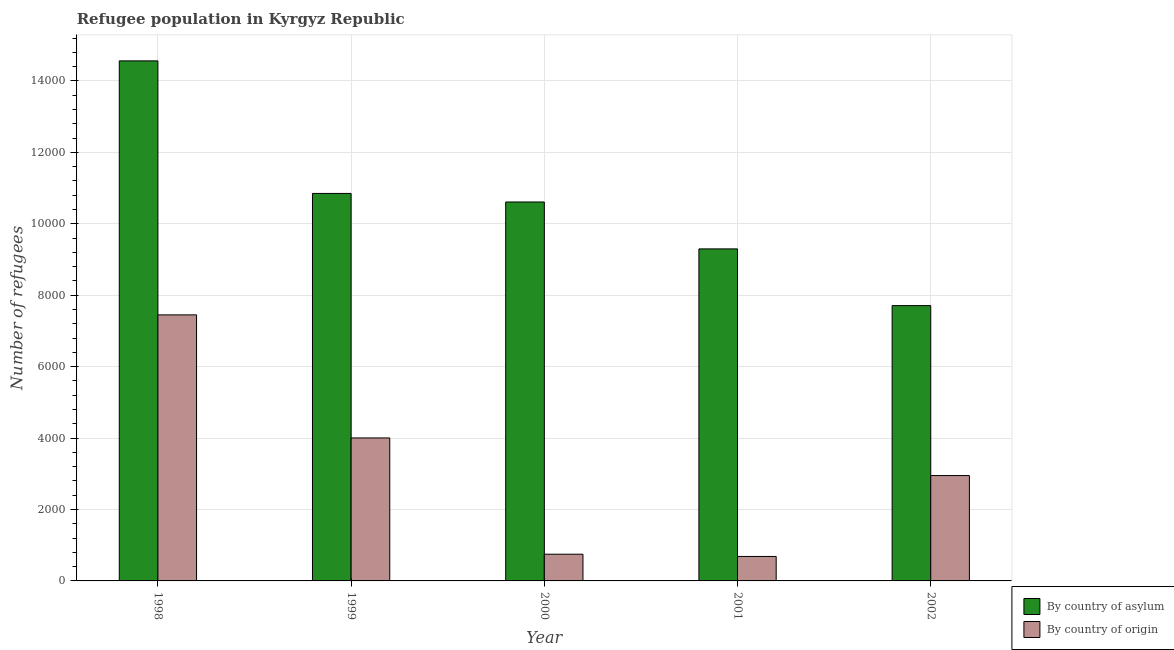How many different coloured bars are there?
Give a very brief answer. 2. What is the label of the 4th group of bars from the left?
Give a very brief answer. 2001. In how many cases, is the number of bars for a given year not equal to the number of legend labels?
Your answer should be compact. 0. What is the number of refugees by country of asylum in 2001?
Provide a short and direct response. 9296. Across all years, what is the maximum number of refugees by country of asylum?
Give a very brief answer. 1.46e+04. Across all years, what is the minimum number of refugees by country of asylum?
Your answer should be very brief. 7708. In which year was the number of refugees by country of asylum maximum?
Your answer should be compact. 1998. In which year was the number of refugees by country of asylum minimum?
Give a very brief answer. 2002. What is the total number of refugees by country of origin in the graph?
Offer a very short reply. 1.58e+04. What is the difference between the number of refugees by country of origin in 1998 and that in 2002?
Your response must be concise. 4499. What is the difference between the number of refugees by country of origin in 1998 and the number of refugees by country of asylum in 2002?
Your response must be concise. 4499. What is the average number of refugees by country of origin per year?
Make the answer very short. 3167. What is the ratio of the number of refugees by country of origin in 2001 to that in 2002?
Offer a very short reply. 0.23. Is the difference between the number of refugees by country of origin in 1999 and 2000 greater than the difference between the number of refugees by country of asylum in 1999 and 2000?
Keep it short and to the point. No. What is the difference between the highest and the second highest number of refugees by country of origin?
Your answer should be very brief. 3446. What is the difference between the highest and the lowest number of refugees by country of origin?
Give a very brief answer. 6764. Is the sum of the number of refugees by country of origin in 1998 and 2002 greater than the maximum number of refugees by country of asylum across all years?
Make the answer very short. Yes. What does the 2nd bar from the left in 1999 represents?
Offer a very short reply. By country of origin. What does the 1st bar from the right in 2001 represents?
Provide a short and direct response. By country of origin. Are all the bars in the graph horizontal?
Keep it short and to the point. No. How many years are there in the graph?
Your answer should be very brief. 5. What is the difference between two consecutive major ticks on the Y-axis?
Give a very brief answer. 2000. Does the graph contain grids?
Your answer should be very brief. Yes. Where does the legend appear in the graph?
Ensure brevity in your answer.  Bottom right. How are the legend labels stacked?
Offer a very short reply. Vertical. What is the title of the graph?
Offer a terse response. Refugee population in Kyrgyz Republic. What is the label or title of the X-axis?
Ensure brevity in your answer.  Year. What is the label or title of the Y-axis?
Your answer should be very brief. Number of refugees. What is the Number of refugees in By country of asylum in 1998?
Your answer should be compact. 1.46e+04. What is the Number of refugees of By country of origin in 1998?
Your response must be concise. 7449. What is the Number of refugees of By country of asylum in 1999?
Give a very brief answer. 1.08e+04. What is the Number of refugees in By country of origin in 1999?
Provide a succinct answer. 4003. What is the Number of refugees of By country of asylum in 2000?
Provide a succinct answer. 1.06e+04. What is the Number of refugees in By country of origin in 2000?
Your response must be concise. 748. What is the Number of refugees of By country of asylum in 2001?
Your answer should be very brief. 9296. What is the Number of refugees of By country of origin in 2001?
Give a very brief answer. 685. What is the Number of refugees in By country of asylum in 2002?
Your answer should be compact. 7708. What is the Number of refugees of By country of origin in 2002?
Make the answer very short. 2950. Across all years, what is the maximum Number of refugees of By country of asylum?
Make the answer very short. 1.46e+04. Across all years, what is the maximum Number of refugees in By country of origin?
Your answer should be very brief. 7449. Across all years, what is the minimum Number of refugees of By country of asylum?
Ensure brevity in your answer.  7708. Across all years, what is the minimum Number of refugees in By country of origin?
Your answer should be very brief. 685. What is the total Number of refugees of By country of asylum in the graph?
Offer a terse response. 5.30e+04. What is the total Number of refugees in By country of origin in the graph?
Offer a very short reply. 1.58e+04. What is the difference between the Number of refugees in By country of asylum in 1998 and that in 1999?
Offer a terse response. 3711. What is the difference between the Number of refugees in By country of origin in 1998 and that in 1999?
Your answer should be very brief. 3446. What is the difference between the Number of refugees in By country of asylum in 1998 and that in 2000?
Provide a short and direct response. 3951. What is the difference between the Number of refugees in By country of origin in 1998 and that in 2000?
Ensure brevity in your answer.  6701. What is the difference between the Number of refugees in By country of asylum in 1998 and that in 2001?
Offer a very short reply. 5264. What is the difference between the Number of refugees in By country of origin in 1998 and that in 2001?
Ensure brevity in your answer.  6764. What is the difference between the Number of refugees in By country of asylum in 1998 and that in 2002?
Keep it short and to the point. 6852. What is the difference between the Number of refugees of By country of origin in 1998 and that in 2002?
Ensure brevity in your answer.  4499. What is the difference between the Number of refugees of By country of asylum in 1999 and that in 2000?
Provide a succinct answer. 240. What is the difference between the Number of refugees in By country of origin in 1999 and that in 2000?
Offer a terse response. 3255. What is the difference between the Number of refugees of By country of asylum in 1999 and that in 2001?
Your answer should be very brief. 1553. What is the difference between the Number of refugees in By country of origin in 1999 and that in 2001?
Your response must be concise. 3318. What is the difference between the Number of refugees of By country of asylum in 1999 and that in 2002?
Provide a short and direct response. 3141. What is the difference between the Number of refugees of By country of origin in 1999 and that in 2002?
Provide a succinct answer. 1053. What is the difference between the Number of refugees of By country of asylum in 2000 and that in 2001?
Give a very brief answer. 1313. What is the difference between the Number of refugees of By country of origin in 2000 and that in 2001?
Offer a very short reply. 63. What is the difference between the Number of refugees of By country of asylum in 2000 and that in 2002?
Provide a succinct answer. 2901. What is the difference between the Number of refugees in By country of origin in 2000 and that in 2002?
Your answer should be compact. -2202. What is the difference between the Number of refugees of By country of asylum in 2001 and that in 2002?
Your answer should be very brief. 1588. What is the difference between the Number of refugees in By country of origin in 2001 and that in 2002?
Make the answer very short. -2265. What is the difference between the Number of refugees of By country of asylum in 1998 and the Number of refugees of By country of origin in 1999?
Your answer should be very brief. 1.06e+04. What is the difference between the Number of refugees of By country of asylum in 1998 and the Number of refugees of By country of origin in 2000?
Your response must be concise. 1.38e+04. What is the difference between the Number of refugees in By country of asylum in 1998 and the Number of refugees in By country of origin in 2001?
Your answer should be compact. 1.39e+04. What is the difference between the Number of refugees of By country of asylum in 1998 and the Number of refugees of By country of origin in 2002?
Make the answer very short. 1.16e+04. What is the difference between the Number of refugees of By country of asylum in 1999 and the Number of refugees of By country of origin in 2000?
Offer a terse response. 1.01e+04. What is the difference between the Number of refugees in By country of asylum in 1999 and the Number of refugees in By country of origin in 2001?
Give a very brief answer. 1.02e+04. What is the difference between the Number of refugees of By country of asylum in 1999 and the Number of refugees of By country of origin in 2002?
Offer a terse response. 7899. What is the difference between the Number of refugees in By country of asylum in 2000 and the Number of refugees in By country of origin in 2001?
Provide a short and direct response. 9924. What is the difference between the Number of refugees in By country of asylum in 2000 and the Number of refugees in By country of origin in 2002?
Provide a short and direct response. 7659. What is the difference between the Number of refugees in By country of asylum in 2001 and the Number of refugees in By country of origin in 2002?
Your answer should be very brief. 6346. What is the average Number of refugees in By country of asylum per year?
Your answer should be compact. 1.06e+04. What is the average Number of refugees in By country of origin per year?
Make the answer very short. 3167. In the year 1998, what is the difference between the Number of refugees in By country of asylum and Number of refugees in By country of origin?
Your answer should be compact. 7111. In the year 1999, what is the difference between the Number of refugees in By country of asylum and Number of refugees in By country of origin?
Your answer should be very brief. 6846. In the year 2000, what is the difference between the Number of refugees of By country of asylum and Number of refugees of By country of origin?
Make the answer very short. 9861. In the year 2001, what is the difference between the Number of refugees of By country of asylum and Number of refugees of By country of origin?
Offer a very short reply. 8611. In the year 2002, what is the difference between the Number of refugees in By country of asylum and Number of refugees in By country of origin?
Keep it short and to the point. 4758. What is the ratio of the Number of refugees in By country of asylum in 1998 to that in 1999?
Ensure brevity in your answer.  1.34. What is the ratio of the Number of refugees of By country of origin in 1998 to that in 1999?
Make the answer very short. 1.86. What is the ratio of the Number of refugees of By country of asylum in 1998 to that in 2000?
Offer a terse response. 1.37. What is the ratio of the Number of refugees in By country of origin in 1998 to that in 2000?
Your answer should be compact. 9.96. What is the ratio of the Number of refugees of By country of asylum in 1998 to that in 2001?
Provide a short and direct response. 1.57. What is the ratio of the Number of refugees in By country of origin in 1998 to that in 2001?
Your answer should be compact. 10.87. What is the ratio of the Number of refugees of By country of asylum in 1998 to that in 2002?
Offer a terse response. 1.89. What is the ratio of the Number of refugees in By country of origin in 1998 to that in 2002?
Provide a succinct answer. 2.53. What is the ratio of the Number of refugees of By country of asylum in 1999 to that in 2000?
Give a very brief answer. 1.02. What is the ratio of the Number of refugees in By country of origin in 1999 to that in 2000?
Provide a succinct answer. 5.35. What is the ratio of the Number of refugees in By country of asylum in 1999 to that in 2001?
Your answer should be very brief. 1.17. What is the ratio of the Number of refugees in By country of origin in 1999 to that in 2001?
Keep it short and to the point. 5.84. What is the ratio of the Number of refugees in By country of asylum in 1999 to that in 2002?
Offer a terse response. 1.41. What is the ratio of the Number of refugees in By country of origin in 1999 to that in 2002?
Provide a succinct answer. 1.36. What is the ratio of the Number of refugees of By country of asylum in 2000 to that in 2001?
Give a very brief answer. 1.14. What is the ratio of the Number of refugees in By country of origin in 2000 to that in 2001?
Offer a very short reply. 1.09. What is the ratio of the Number of refugees of By country of asylum in 2000 to that in 2002?
Give a very brief answer. 1.38. What is the ratio of the Number of refugees in By country of origin in 2000 to that in 2002?
Your answer should be very brief. 0.25. What is the ratio of the Number of refugees of By country of asylum in 2001 to that in 2002?
Offer a very short reply. 1.21. What is the ratio of the Number of refugees in By country of origin in 2001 to that in 2002?
Make the answer very short. 0.23. What is the difference between the highest and the second highest Number of refugees in By country of asylum?
Offer a very short reply. 3711. What is the difference between the highest and the second highest Number of refugees in By country of origin?
Offer a terse response. 3446. What is the difference between the highest and the lowest Number of refugees of By country of asylum?
Ensure brevity in your answer.  6852. What is the difference between the highest and the lowest Number of refugees in By country of origin?
Your response must be concise. 6764. 